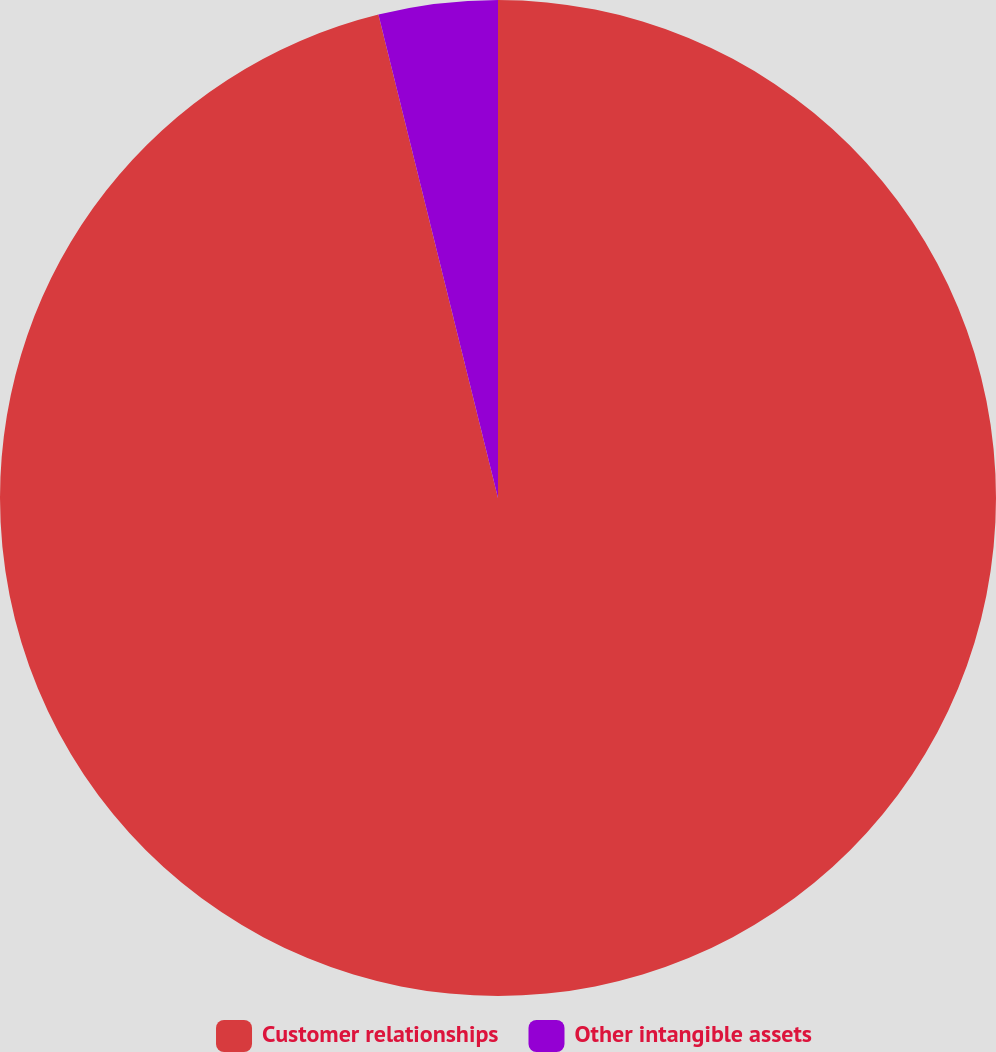Convert chart to OTSL. <chart><loc_0><loc_0><loc_500><loc_500><pie_chart><fcel>Customer relationships<fcel>Other intangible assets<nl><fcel>96.14%<fcel>3.86%<nl></chart> 